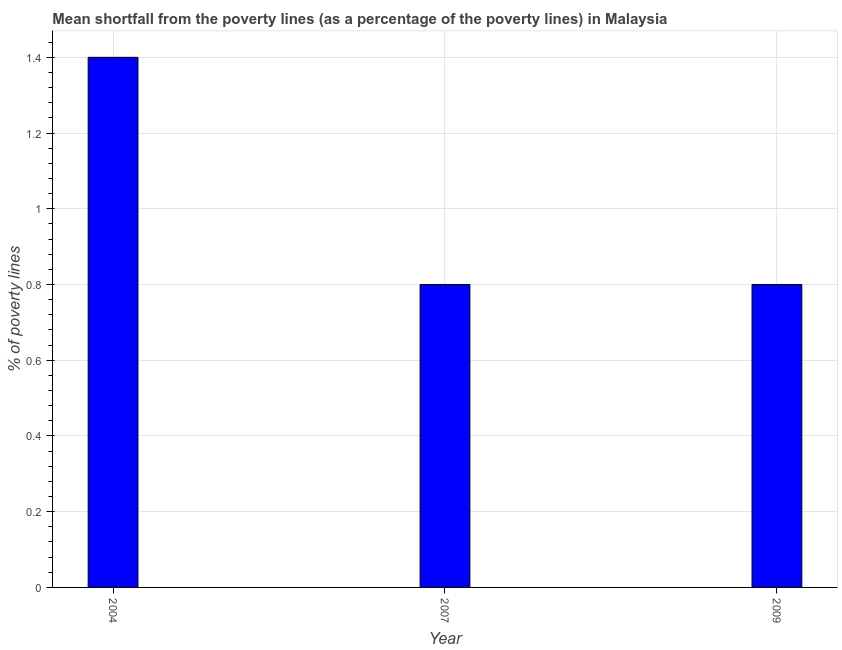Does the graph contain grids?
Offer a terse response. Yes. What is the title of the graph?
Your response must be concise. Mean shortfall from the poverty lines (as a percentage of the poverty lines) in Malaysia. What is the label or title of the X-axis?
Ensure brevity in your answer.  Year. What is the label or title of the Y-axis?
Your answer should be very brief. % of poverty lines. What is the poverty gap at national poverty lines in 2007?
Give a very brief answer. 0.8. Across all years, what is the maximum poverty gap at national poverty lines?
Your answer should be very brief. 1.4. Across all years, what is the minimum poverty gap at national poverty lines?
Provide a short and direct response. 0.8. In which year was the poverty gap at national poverty lines maximum?
Provide a succinct answer. 2004. In which year was the poverty gap at national poverty lines minimum?
Offer a terse response. 2007. What is the average poverty gap at national poverty lines per year?
Keep it short and to the point. 1. Do a majority of the years between 2009 and 2007 (inclusive) have poverty gap at national poverty lines greater than 1.36 %?
Your answer should be very brief. No. Is the difference between the poverty gap at national poverty lines in 2004 and 2007 greater than the difference between any two years?
Give a very brief answer. Yes. What is the difference between the highest and the second highest poverty gap at national poverty lines?
Provide a succinct answer. 0.6. How many years are there in the graph?
Offer a very short reply. 3. What is the % of poverty lines in 2009?
Offer a terse response. 0.8. What is the difference between the % of poverty lines in 2004 and 2007?
Give a very brief answer. 0.6. What is the difference between the % of poverty lines in 2004 and 2009?
Keep it short and to the point. 0.6. What is the difference between the % of poverty lines in 2007 and 2009?
Make the answer very short. 0. 